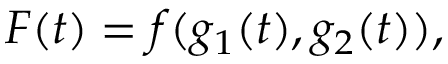Convert formula to latex. <formula><loc_0><loc_0><loc_500><loc_500>F ( t ) = f ( g _ { 1 } ( t ) , g _ { 2 } ( t ) ) ,</formula> 